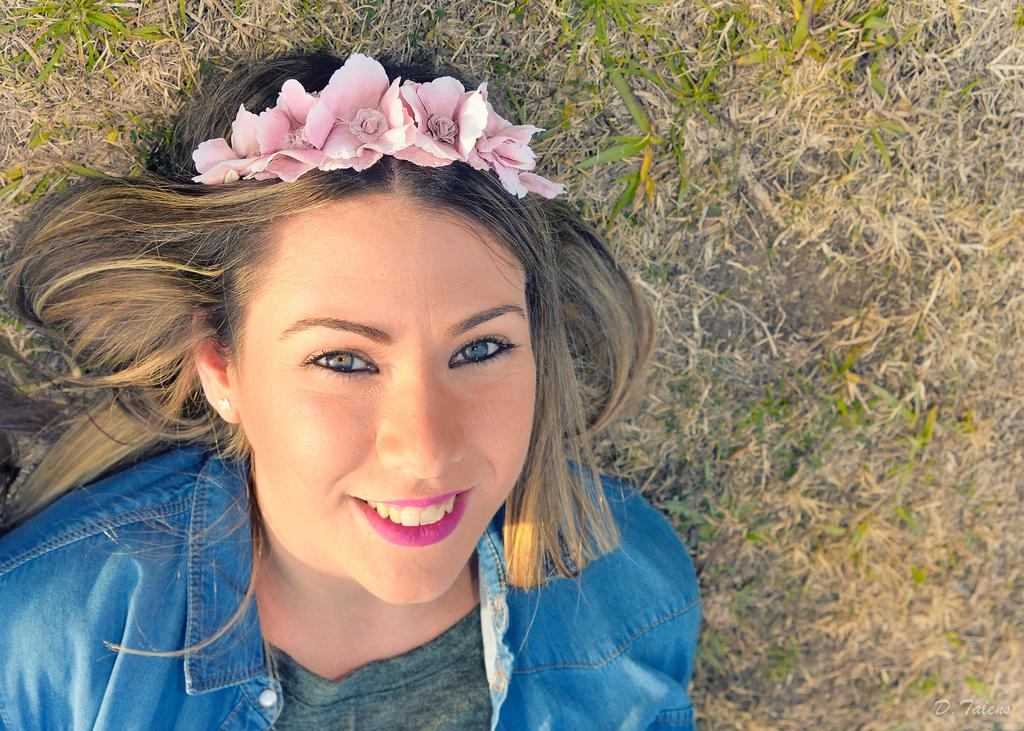Who is the main subject in the foreground of the image? There is a woman in the foreground of the image. What is the woman wearing in the image? The woman is wearing a blue jacket in the image. What is the woman doing in the image? The woman is lying on the grass land in the image. What accessory is the woman wearing on her head? The woman is wearing a flower crown on her head in the image. Can you see a kitten touching the woman's finger in the image? There is no kitten or touching of fingers present in the image. 